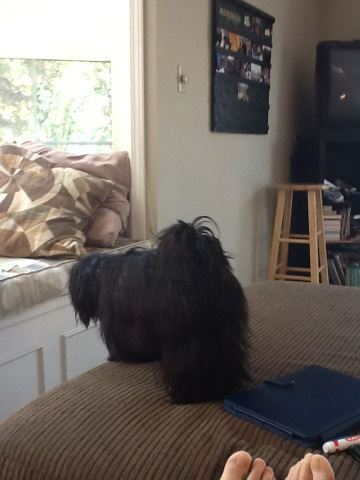Describe the setting where the dog is. The dog is indoors, appearing to be on a cozy piece of furniture. There is a window nearby letting in natural light, a wooden stool, and visible shelves or furniture that suggests a comfortable living space. What do you think the dog is looking at? The dog seems to be intently looking out the window. Perhaps it is watching something happening outside, such as birds, another animal, or simply enjoying the view and keeping an eye on its surroundings. Imagine this dog was on an adventure. Where would it go and what would it discover? If this adventurous little dog went on an escapade, it might explore a magical forest where the trees whisper stories and the streams sing melodies. It could meet friendly woodland creatures, discover hidden paths adorned with sparkling fairy lights, and perhaps even find a secret cave with ancient treasures guarded by wise old owls. The dog would play, discover new scents, and maybe even have a brave encounter with a mischievous, yet kind-hearted fox who offers it a special leaf that grants the power to understand all the animals of the forest. 